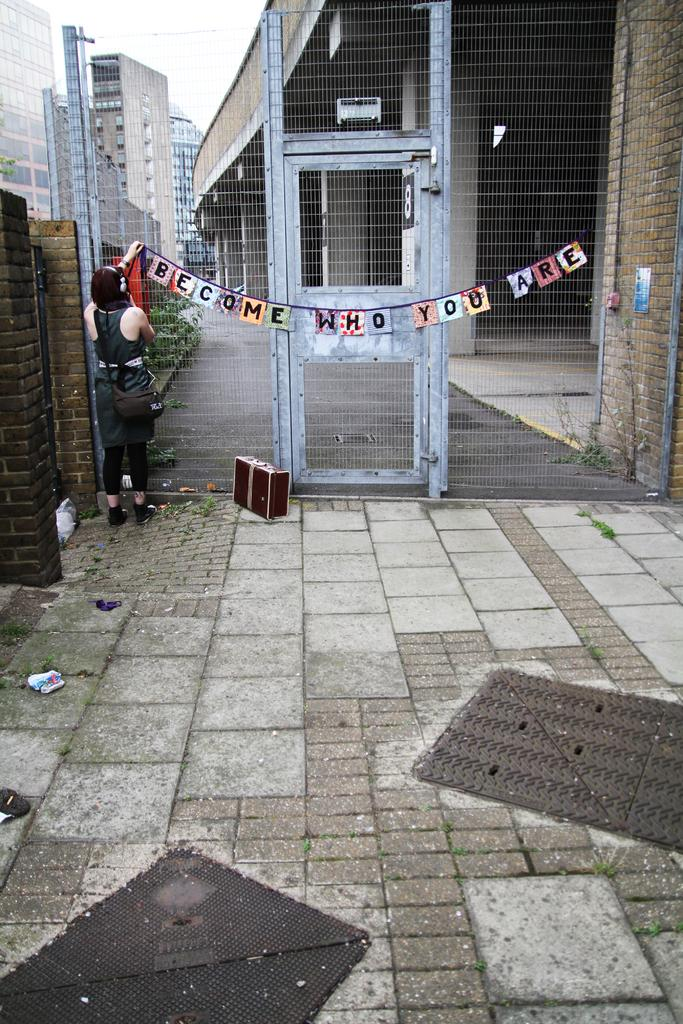<image>
Give a short and clear explanation of the subsequent image. A banner is in front of a gate that reads Welcome who you are. 